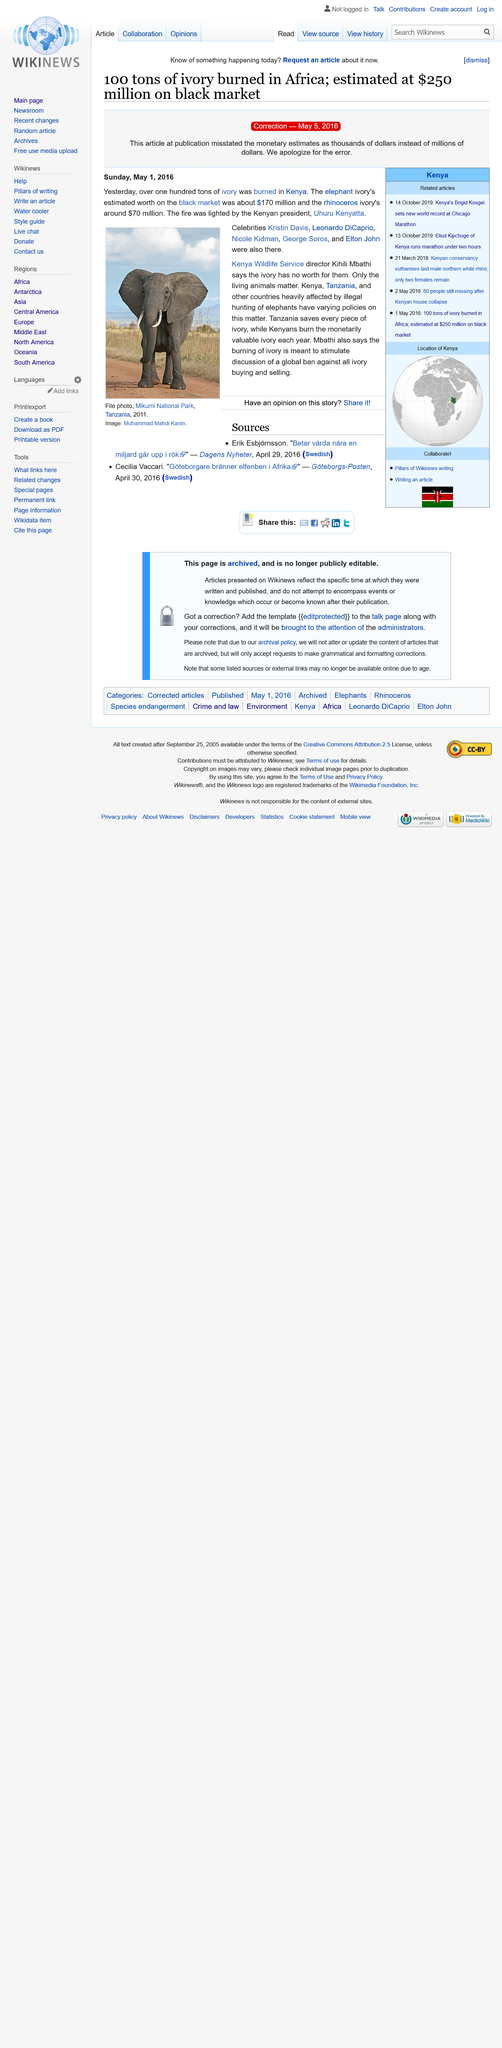Outline some significant characteristics in this image. It is reported that five celebrities were present at the burning. Kihili Mbathi is the director of the Kenya Wildlife Service. The estimated total value of the ivory burned was $240 million. 